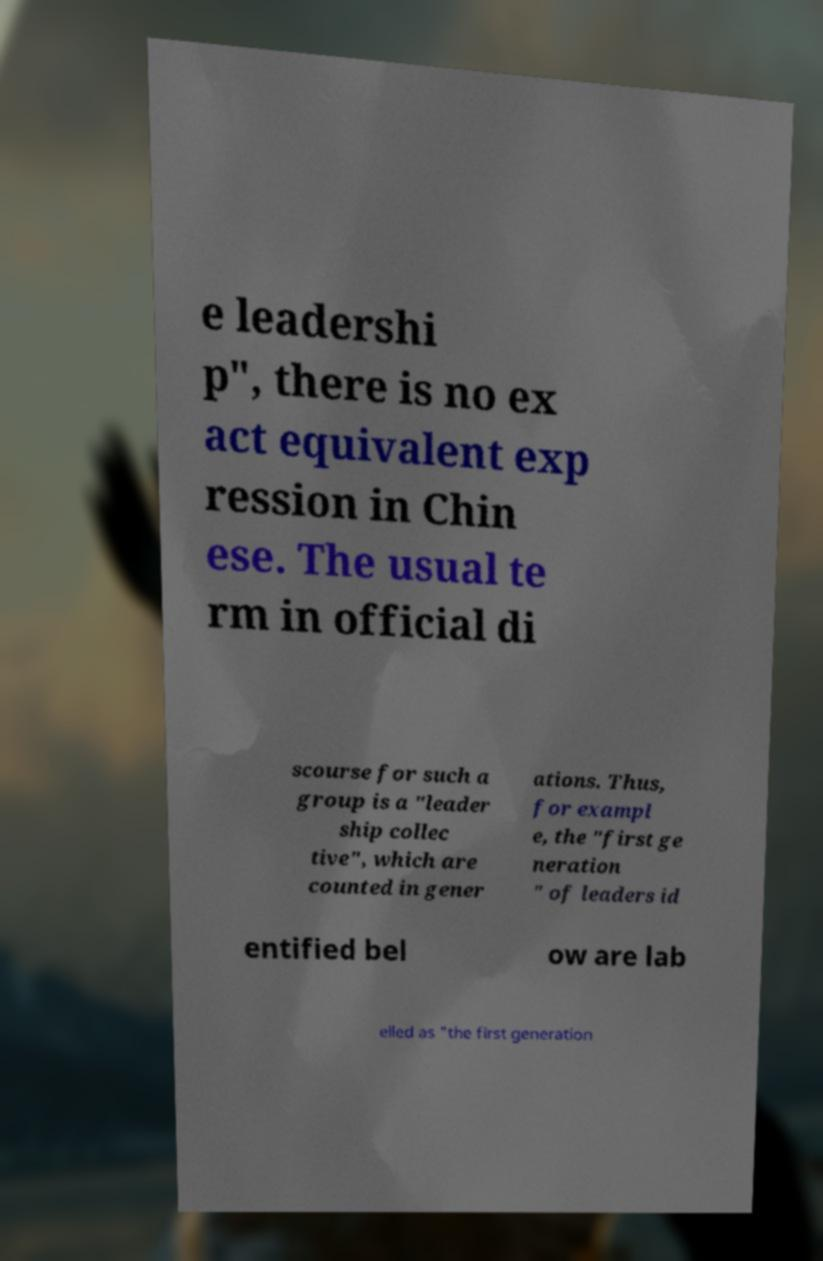There's text embedded in this image that I need extracted. Can you transcribe it verbatim? e leadershi p", there is no ex act equivalent exp ression in Chin ese. The usual te rm in official di scourse for such a group is a "leader ship collec tive", which are counted in gener ations. Thus, for exampl e, the "first ge neration " of leaders id entified bel ow are lab elled as "the first generation 